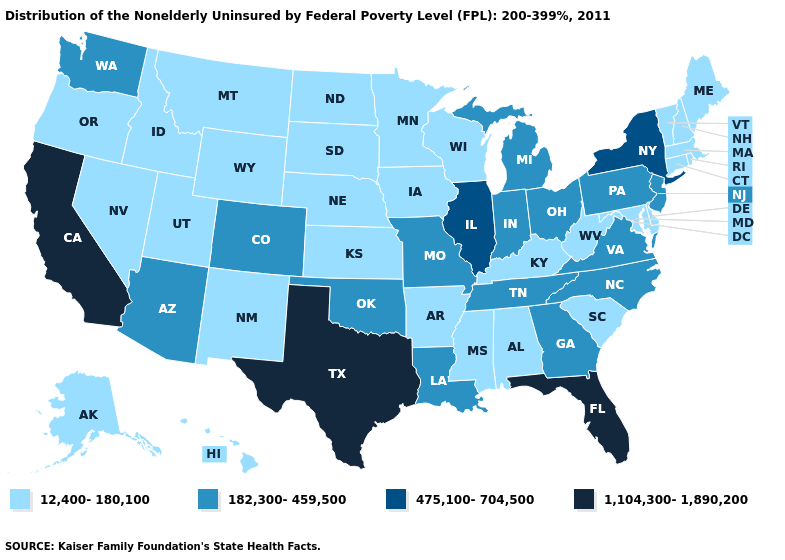Among the states that border Alabama , which have the highest value?
Give a very brief answer. Florida. Does New Mexico have the same value as Montana?
Write a very short answer. Yes. How many symbols are there in the legend?
Quick response, please. 4. Does Delaware have a lower value than Pennsylvania?
Keep it brief. Yes. How many symbols are there in the legend?
Write a very short answer. 4. Which states have the highest value in the USA?
Quick response, please. California, Florida, Texas. Does Pennsylvania have the lowest value in the USA?
Concise answer only. No. Name the states that have a value in the range 12,400-180,100?
Answer briefly. Alabama, Alaska, Arkansas, Connecticut, Delaware, Hawaii, Idaho, Iowa, Kansas, Kentucky, Maine, Maryland, Massachusetts, Minnesota, Mississippi, Montana, Nebraska, Nevada, New Hampshire, New Mexico, North Dakota, Oregon, Rhode Island, South Carolina, South Dakota, Utah, Vermont, West Virginia, Wisconsin, Wyoming. What is the value of Louisiana?
Keep it brief. 182,300-459,500. Name the states that have a value in the range 12,400-180,100?
Quick response, please. Alabama, Alaska, Arkansas, Connecticut, Delaware, Hawaii, Idaho, Iowa, Kansas, Kentucky, Maine, Maryland, Massachusetts, Minnesota, Mississippi, Montana, Nebraska, Nevada, New Hampshire, New Mexico, North Dakota, Oregon, Rhode Island, South Carolina, South Dakota, Utah, Vermont, West Virginia, Wisconsin, Wyoming. Name the states that have a value in the range 1,104,300-1,890,200?
Be succinct. California, Florida, Texas. What is the lowest value in the USA?
Be succinct. 12,400-180,100. Name the states that have a value in the range 475,100-704,500?
Write a very short answer. Illinois, New York. Which states have the lowest value in the MidWest?
Answer briefly. Iowa, Kansas, Minnesota, Nebraska, North Dakota, South Dakota, Wisconsin. 